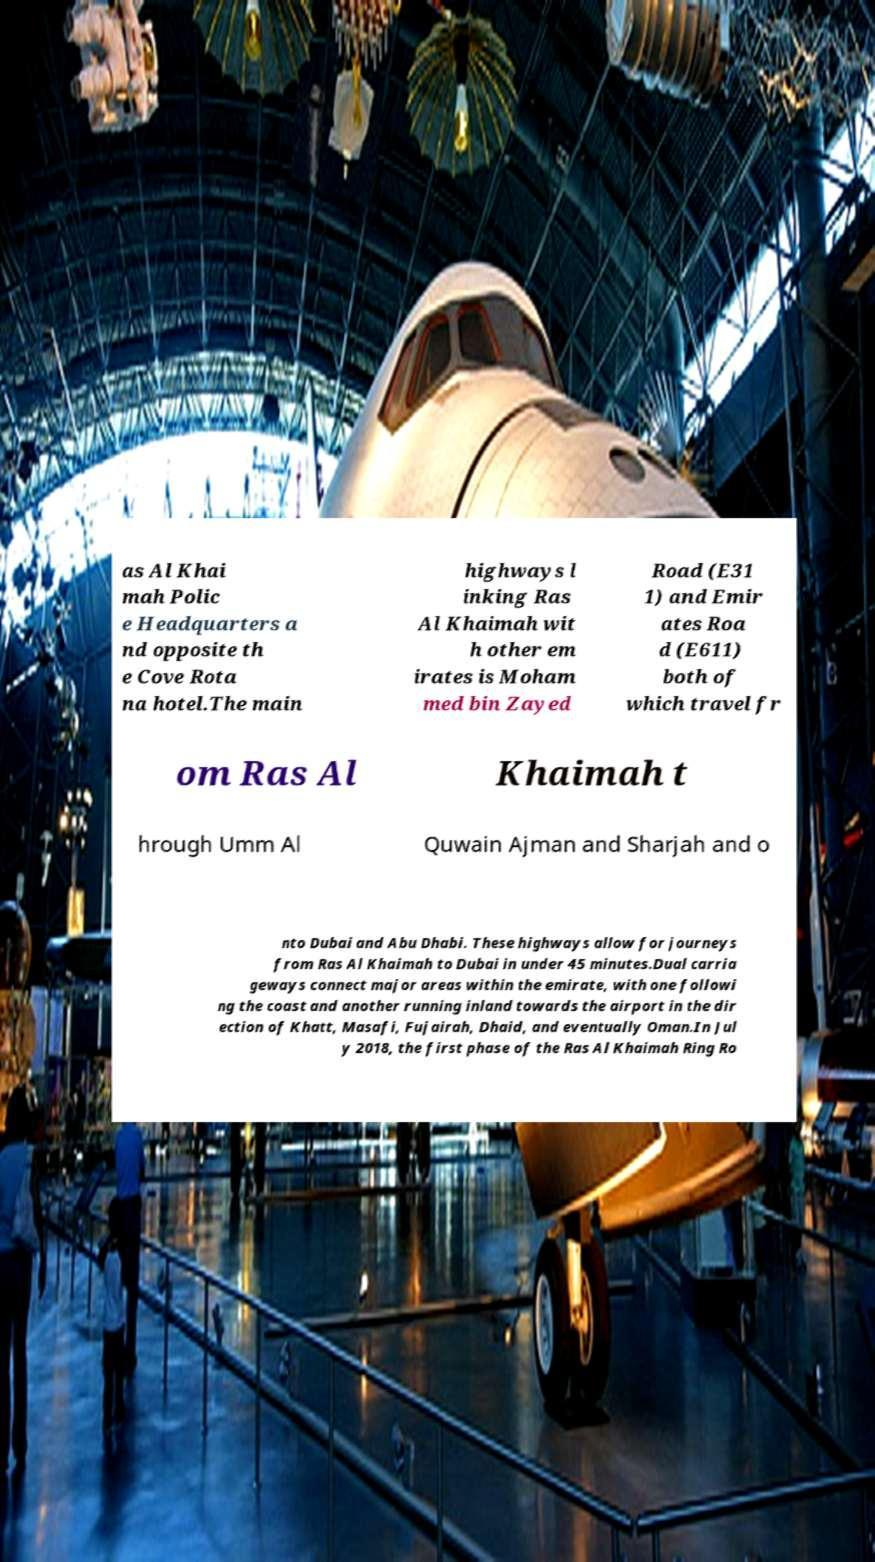I need the written content from this picture converted into text. Can you do that? as Al Khai mah Polic e Headquarters a nd opposite th e Cove Rota na hotel.The main highways l inking Ras Al Khaimah wit h other em irates is Moham med bin Zayed Road (E31 1) and Emir ates Roa d (E611) both of which travel fr om Ras Al Khaimah t hrough Umm Al Quwain Ajman and Sharjah and o nto Dubai and Abu Dhabi. These highways allow for journeys from Ras Al Khaimah to Dubai in under 45 minutes.Dual carria geways connect major areas within the emirate, with one followi ng the coast and another running inland towards the airport in the dir ection of Khatt, Masafi, Fujairah, Dhaid, and eventually Oman.In Jul y 2018, the first phase of the Ras Al Khaimah Ring Ro 